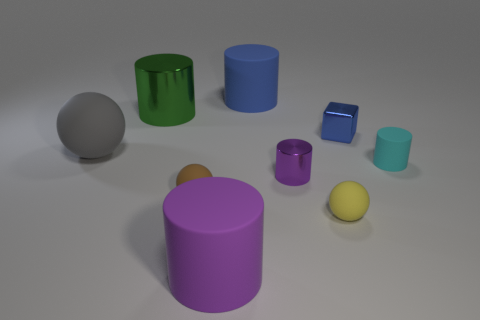Subtract all green cylinders. How many cylinders are left? 4 Subtract all blue rubber cylinders. How many cylinders are left? 4 Subtract 1 cylinders. How many cylinders are left? 4 Subtract all brown cylinders. Subtract all brown blocks. How many cylinders are left? 5 Add 1 purple cylinders. How many objects exist? 10 Subtract all cylinders. How many objects are left? 4 Subtract all large red metal things. Subtract all big rubber cylinders. How many objects are left? 7 Add 9 green cylinders. How many green cylinders are left? 10 Add 6 large cylinders. How many large cylinders exist? 9 Subtract 0 purple spheres. How many objects are left? 9 